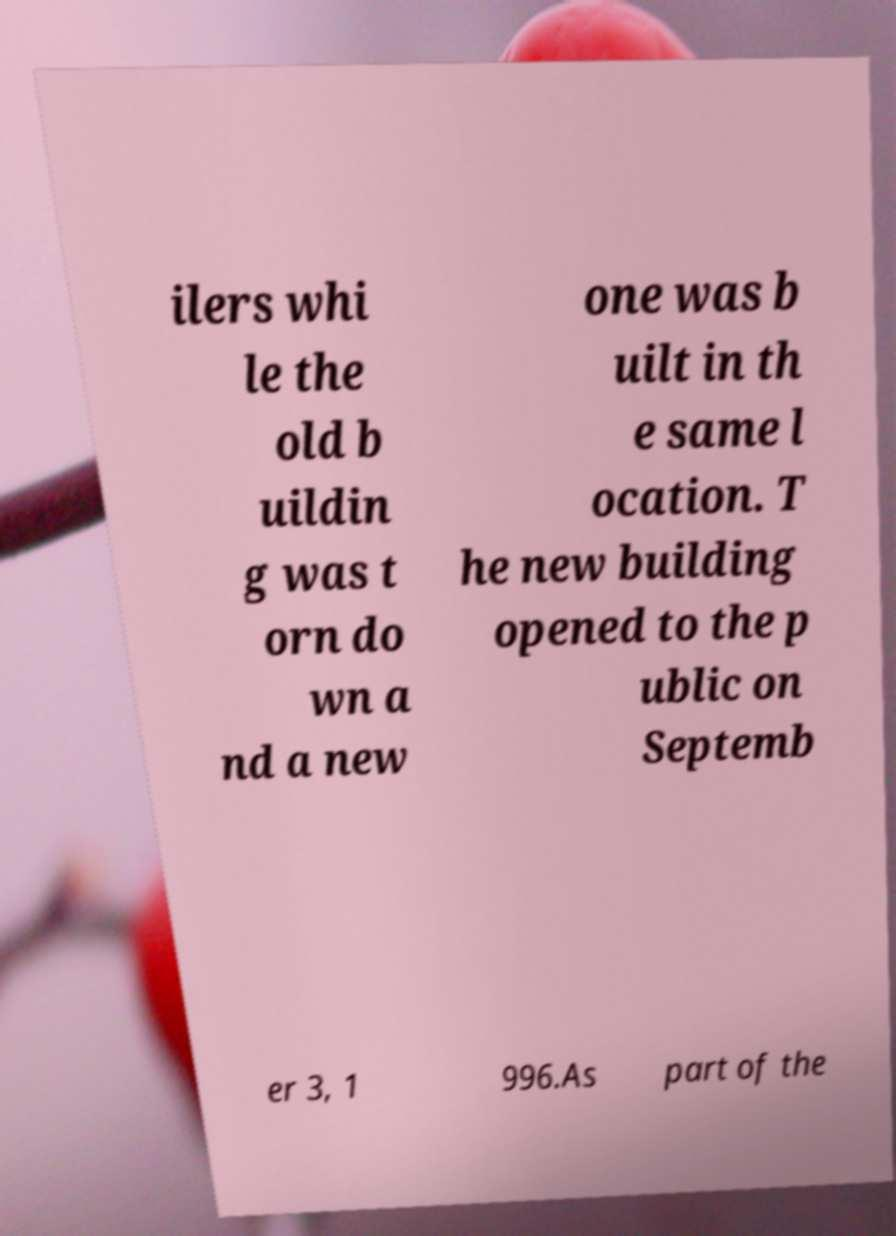Please read and relay the text visible in this image. What does it say? ilers whi le the old b uildin g was t orn do wn a nd a new one was b uilt in th e same l ocation. T he new building opened to the p ublic on Septemb er 3, 1 996.As part of the 